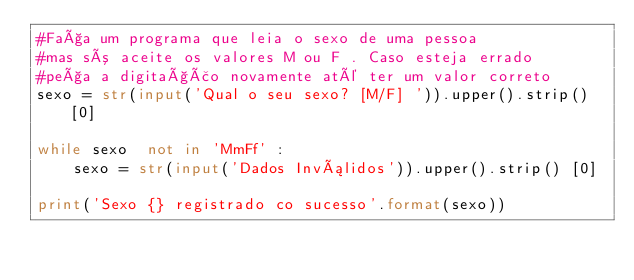<code> <loc_0><loc_0><loc_500><loc_500><_Python_>#Faça um programa que leia o sexo de uma pessoa
#mas só aceite os valores M ou F . Caso esteja errado
#peça a digitação novamente até ter um valor correto
sexo = str(input('Qual o seu sexo? [M/F] ')).upper().strip()[0]

while sexo  not in 'MmFf' :
    sexo = str(input('Dados Inválidos')).upper().strip() [0]
    
print('Sexo {} registrado co sucesso'.format(sexo))
    
</code> 